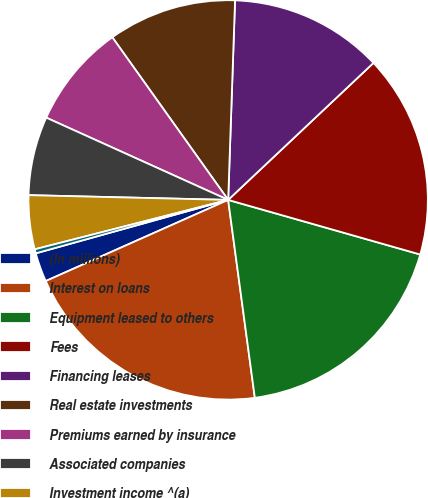<chart> <loc_0><loc_0><loc_500><loc_500><pie_chart><fcel>(In millions)<fcel>Interest on loans<fcel>Equipment leased to others<fcel>Fees<fcel>Financing leases<fcel>Real estate investments<fcel>Premiums earned by insurance<fcel>Associated companies<fcel>Investment income ^(a)<fcel>Net securitization gains<nl><fcel>2.35%<fcel>20.47%<fcel>18.46%<fcel>16.44%<fcel>12.42%<fcel>10.4%<fcel>8.39%<fcel>6.38%<fcel>4.36%<fcel>0.33%<nl></chart> 